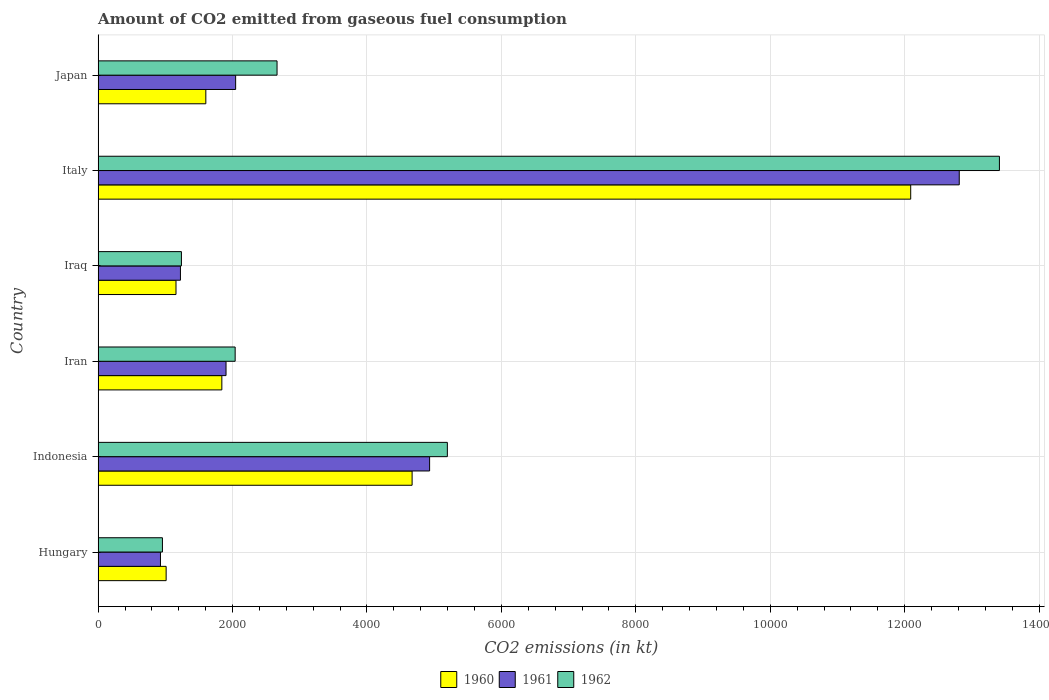How many different coloured bars are there?
Provide a short and direct response. 3. How many groups of bars are there?
Offer a terse response. 6. In how many cases, is the number of bars for a given country not equal to the number of legend labels?
Ensure brevity in your answer.  0. What is the amount of CO2 emitted in 1960 in Hungary?
Your response must be concise. 1012.09. Across all countries, what is the maximum amount of CO2 emitted in 1961?
Offer a terse response. 1.28e+04. Across all countries, what is the minimum amount of CO2 emitted in 1961?
Ensure brevity in your answer.  927.75. In which country was the amount of CO2 emitted in 1960 minimum?
Ensure brevity in your answer.  Hungary. What is the total amount of CO2 emitted in 1962 in the graph?
Provide a succinct answer. 2.55e+04. What is the difference between the amount of CO2 emitted in 1961 in Hungary and that in Iraq?
Provide a short and direct response. -297.03. What is the difference between the amount of CO2 emitted in 1960 in Iran and the amount of CO2 emitted in 1962 in Indonesia?
Keep it short and to the point. -3355.31. What is the average amount of CO2 emitted in 1962 per country?
Offer a very short reply. 4250.66. What is the difference between the amount of CO2 emitted in 1961 and amount of CO2 emitted in 1960 in Hungary?
Provide a succinct answer. -84.34. In how many countries, is the amount of CO2 emitted in 1962 greater than 12000 kt?
Give a very brief answer. 1. What is the ratio of the amount of CO2 emitted in 1962 in Indonesia to that in Japan?
Offer a terse response. 1.95. Is the amount of CO2 emitted in 1962 in Iran less than that in Japan?
Keep it short and to the point. Yes. Is the difference between the amount of CO2 emitted in 1961 in Iran and Italy greater than the difference between the amount of CO2 emitted in 1960 in Iran and Italy?
Offer a very short reply. No. What is the difference between the highest and the second highest amount of CO2 emitted in 1961?
Your answer should be compact. 7880.38. What is the difference between the highest and the lowest amount of CO2 emitted in 1961?
Provide a succinct answer. 1.19e+04. Is the sum of the amount of CO2 emitted in 1960 in Hungary and Iraq greater than the maximum amount of CO2 emitted in 1962 across all countries?
Your response must be concise. No. What does the 1st bar from the top in Iran represents?
Give a very brief answer. 1962. What does the 2nd bar from the bottom in Italy represents?
Ensure brevity in your answer.  1961. Is it the case that in every country, the sum of the amount of CO2 emitted in 1960 and amount of CO2 emitted in 1962 is greater than the amount of CO2 emitted in 1961?
Your answer should be very brief. Yes. What is the difference between two consecutive major ticks on the X-axis?
Provide a succinct answer. 2000. Are the values on the major ticks of X-axis written in scientific E-notation?
Provide a succinct answer. No. What is the title of the graph?
Keep it short and to the point. Amount of CO2 emitted from gaseous fuel consumption. What is the label or title of the X-axis?
Ensure brevity in your answer.  CO2 emissions (in kt). What is the label or title of the Y-axis?
Your response must be concise. Country. What is the CO2 emissions (in kt) in 1960 in Hungary?
Your answer should be very brief. 1012.09. What is the CO2 emissions (in kt) in 1961 in Hungary?
Keep it short and to the point. 927.75. What is the CO2 emissions (in kt) in 1962 in Hungary?
Provide a short and direct response. 957.09. What is the CO2 emissions (in kt) of 1960 in Indonesia?
Your answer should be very brief. 4671.76. What is the CO2 emissions (in kt) of 1961 in Indonesia?
Your response must be concise. 4932.11. What is the CO2 emissions (in kt) in 1962 in Indonesia?
Offer a very short reply. 5196.14. What is the CO2 emissions (in kt) in 1960 in Iran?
Your answer should be compact. 1840.83. What is the CO2 emissions (in kt) of 1961 in Iran?
Provide a short and direct response. 1903.17. What is the CO2 emissions (in kt) of 1962 in Iran?
Ensure brevity in your answer.  2038.85. What is the CO2 emissions (in kt) of 1960 in Iraq?
Offer a very short reply. 1158.77. What is the CO2 emissions (in kt) in 1961 in Iraq?
Offer a very short reply. 1224.78. What is the CO2 emissions (in kt) of 1962 in Iraq?
Your answer should be compact. 1239.45. What is the CO2 emissions (in kt) in 1960 in Italy?
Make the answer very short. 1.21e+04. What is the CO2 emissions (in kt) of 1961 in Italy?
Make the answer very short. 1.28e+04. What is the CO2 emissions (in kt) in 1962 in Italy?
Make the answer very short. 1.34e+04. What is the CO2 emissions (in kt) of 1960 in Japan?
Provide a succinct answer. 1602.48. What is the CO2 emissions (in kt) of 1961 in Japan?
Provide a short and direct response. 2046.19. What is the CO2 emissions (in kt) of 1962 in Japan?
Provide a succinct answer. 2662.24. Across all countries, what is the maximum CO2 emissions (in kt) of 1960?
Your response must be concise. 1.21e+04. Across all countries, what is the maximum CO2 emissions (in kt) in 1961?
Your answer should be compact. 1.28e+04. Across all countries, what is the maximum CO2 emissions (in kt) of 1962?
Your answer should be compact. 1.34e+04. Across all countries, what is the minimum CO2 emissions (in kt) of 1960?
Make the answer very short. 1012.09. Across all countries, what is the minimum CO2 emissions (in kt) in 1961?
Make the answer very short. 927.75. Across all countries, what is the minimum CO2 emissions (in kt) in 1962?
Provide a short and direct response. 957.09. What is the total CO2 emissions (in kt) of 1960 in the graph?
Your response must be concise. 2.24e+04. What is the total CO2 emissions (in kt) of 1961 in the graph?
Keep it short and to the point. 2.38e+04. What is the total CO2 emissions (in kt) in 1962 in the graph?
Your answer should be very brief. 2.55e+04. What is the difference between the CO2 emissions (in kt) of 1960 in Hungary and that in Indonesia?
Give a very brief answer. -3659.67. What is the difference between the CO2 emissions (in kt) in 1961 in Hungary and that in Indonesia?
Give a very brief answer. -4004.36. What is the difference between the CO2 emissions (in kt) in 1962 in Hungary and that in Indonesia?
Provide a short and direct response. -4239.05. What is the difference between the CO2 emissions (in kt) of 1960 in Hungary and that in Iran?
Give a very brief answer. -828.74. What is the difference between the CO2 emissions (in kt) of 1961 in Hungary and that in Iran?
Your response must be concise. -975.42. What is the difference between the CO2 emissions (in kt) of 1962 in Hungary and that in Iran?
Ensure brevity in your answer.  -1081.77. What is the difference between the CO2 emissions (in kt) in 1960 in Hungary and that in Iraq?
Your answer should be compact. -146.68. What is the difference between the CO2 emissions (in kt) of 1961 in Hungary and that in Iraq?
Your response must be concise. -297.03. What is the difference between the CO2 emissions (in kt) in 1962 in Hungary and that in Iraq?
Provide a short and direct response. -282.36. What is the difference between the CO2 emissions (in kt) in 1960 in Hungary and that in Italy?
Provide a succinct answer. -1.11e+04. What is the difference between the CO2 emissions (in kt) in 1961 in Hungary and that in Italy?
Offer a very short reply. -1.19e+04. What is the difference between the CO2 emissions (in kt) in 1962 in Hungary and that in Italy?
Offer a terse response. -1.25e+04. What is the difference between the CO2 emissions (in kt) in 1960 in Hungary and that in Japan?
Give a very brief answer. -590.39. What is the difference between the CO2 emissions (in kt) in 1961 in Hungary and that in Japan?
Provide a short and direct response. -1118.43. What is the difference between the CO2 emissions (in kt) in 1962 in Hungary and that in Japan?
Make the answer very short. -1705.15. What is the difference between the CO2 emissions (in kt) of 1960 in Indonesia and that in Iran?
Your response must be concise. 2830.92. What is the difference between the CO2 emissions (in kt) in 1961 in Indonesia and that in Iran?
Your answer should be very brief. 3028.94. What is the difference between the CO2 emissions (in kt) of 1962 in Indonesia and that in Iran?
Your response must be concise. 3157.29. What is the difference between the CO2 emissions (in kt) in 1960 in Indonesia and that in Iraq?
Keep it short and to the point. 3512.99. What is the difference between the CO2 emissions (in kt) of 1961 in Indonesia and that in Iraq?
Offer a very short reply. 3707.34. What is the difference between the CO2 emissions (in kt) of 1962 in Indonesia and that in Iraq?
Offer a terse response. 3956.69. What is the difference between the CO2 emissions (in kt) in 1960 in Indonesia and that in Italy?
Offer a very short reply. -7418.34. What is the difference between the CO2 emissions (in kt) of 1961 in Indonesia and that in Italy?
Your response must be concise. -7880.38. What is the difference between the CO2 emissions (in kt) in 1962 in Indonesia and that in Italy?
Keep it short and to the point. -8214.08. What is the difference between the CO2 emissions (in kt) in 1960 in Indonesia and that in Japan?
Your answer should be very brief. 3069.28. What is the difference between the CO2 emissions (in kt) of 1961 in Indonesia and that in Japan?
Offer a terse response. 2885.93. What is the difference between the CO2 emissions (in kt) of 1962 in Indonesia and that in Japan?
Provide a short and direct response. 2533.9. What is the difference between the CO2 emissions (in kt) in 1960 in Iran and that in Iraq?
Make the answer very short. 682.06. What is the difference between the CO2 emissions (in kt) in 1961 in Iran and that in Iraq?
Your response must be concise. 678.39. What is the difference between the CO2 emissions (in kt) of 1962 in Iran and that in Iraq?
Your answer should be compact. 799.41. What is the difference between the CO2 emissions (in kt) of 1960 in Iran and that in Italy?
Your answer should be compact. -1.02e+04. What is the difference between the CO2 emissions (in kt) in 1961 in Iran and that in Italy?
Provide a succinct answer. -1.09e+04. What is the difference between the CO2 emissions (in kt) of 1962 in Iran and that in Italy?
Your answer should be compact. -1.14e+04. What is the difference between the CO2 emissions (in kt) of 1960 in Iran and that in Japan?
Give a very brief answer. 238.35. What is the difference between the CO2 emissions (in kt) of 1961 in Iran and that in Japan?
Keep it short and to the point. -143.01. What is the difference between the CO2 emissions (in kt) in 1962 in Iran and that in Japan?
Ensure brevity in your answer.  -623.39. What is the difference between the CO2 emissions (in kt) of 1960 in Iraq and that in Italy?
Your answer should be very brief. -1.09e+04. What is the difference between the CO2 emissions (in kt) in 1961 in Iraq and that in Italy?
Offer a very short reply. -1.16e+04. What is the difference between the CO2 emissions (in kt) of 1962 in Iraq and that in Italy?
Keep it short and to the point. -1.22e+04. What is the difference between the CO2 emissions (in kt) in 1960 in Iraq and that in Japan?
Provide a succinct answer. -443.71. What is the difference between the CO2 emissions (in kt) in 1961 in Iraq and that in Japan?
Offer a terse response. -821.41. What is the difference between the CO2 emissions (in kt) of 1962 in Iraq and that in Japan?
Provide a succinct answer. -1422.8. What is the difference between the CO2 emissions (in kt) in 1960 in Italy and that in Japan?
Make the answer very short. 1.05e+04. What is the difference between the CO2 emissions (in kt) of 1961 in Italy and that in Japan?
Your answer should be very brief. 1.08e+04. What is the difference between the CO2 emissions (in kt) of 1962 in Italy and that in Japan?
Ensure brevity in your answer.  1.07e+04. What is the difference between the CO2 emissions (in kt) of 1960 in Hungary and the CO2 emissions (in kt) of 1961 in Indonesia?
Your answer should be very brief. -3920.02. What is the difference between the CO2 emissions (in kt) of 1960 in Hungary and the CO2 emissions (in kt) of 1962 in Indonesia?
Provide a short and direct response. -4184.05. What is the difference between the CO2 emissions (in kt) in 1961 in Hungary and the CO2 emissions (in kt) in 1962 in Indonesia?
Offer a very short reply. -4268.39. What is the difference between the CO2 emissions (in kt) of 1960 in Hungary and the CO2 emissions (in kt) of 1961 in Iran?
Ensure brevity in your answer.  -891.08. What is the difference between the CO2 emissions (in kt) of 1960 in Hungary and the CO2 emissions (in kt) of 1962 in Iran?
Provide a short and direct response. -1026.76. What is the difference between the CO2 emissions (in kt) in 1961 in Hungary and the CO2 emissions (in kt) in 1962 in Iran?
Offer a very short reply. -1111.1. What is the difference between the CO2 emissions (in kt) in 1960 in Hungary and the CO2 emissions (in kt) in 1961 in Iraq?
Keep it short and to the point. -212.69. What is the difference between the CO2 emissions (in kt) of 1960 in Hungary and the CO2 emissions (in kt) of 1962 in Iraq?
Give a very brief answer. -227.35. What is the difference between the CO2 emissions (in kt) in 1961 in Hungary and the CO2 emissions (in kt) in 1962 in Iraq?
Give a very brief answer. -311.69. What is the difference between the CO2 emissions (in kt) in 1960 in Hungary and the CO2 emissions (in kt) in 1961 in Italy?
Make the answer very short. -1.18e+04. What is the difference between the CO2 emissions (in kt) of 1960 in Hungary and the CO2 emissions (in kt) of 1962 in Italy?
Your answer should be very brief. -1.24e+04. What is the difference between the CO2 emissions (in kt) in 1961 in Hungary and the CO2 emissions (in kt) in 1962 in Italy?
Ensure brevity in your answer.  -1.25e+04. What is the difference between the CO2 emissions (in kt) of 1960 in Hungary and the CO2 emissions (in kt) of 1961 in Japan?
Provide a succinct answer. -1034.09. What is the difference between the CO2 emissions (in kt) of 1960 in Hungary and the CO2 emissions (in kt) of 1962 in Japan?
Offer a terse response. -1650.15. What is the difference between the CO2 emissions (in kt) in 1961 in Hungary and the CO2 emissions (in kt) in 1962 in Japan?
Provide a succinct answer. -1734.49. What is the difference between the CO2 emissions (in kt) of 1960 in Indonesia and the CO2 emissions (in kt) of 1961 in Iran?
Give a very brief answer. 2768.59. What is the difference between the CO2 emissions (in kt) in 1960 in Indonesia and the CO2 emissions (in kt) in 1962 in Iran?
Offer a terse response. 2632.91. What is the difference between the CO2 emissions (in kt) of 1961 in Indonesia and the CO2 emissions (in kt) of 1962 in Iran?
Keep it short and to the point. 2893.26. What is the difference between the CO2 emissions (in kt) in 1960 in Indonesia and the CO2 emissions (in kt) in 1961 in Iraq?
Your answer should be compact. 3446.98. What is the difference between the CO2 emissions (in kt) in 1960 in Indonesia and the CO2 emissions (in kt) in 1962 in Iraq?
Offer a terse response. 3432.31. What is the difference between the CO2 emissions (in kt) of 1961 in Indonesia and the CO2 emissions (in kt) of 1962 in Iraq?
Offer a very short reply. 3692.67. What is the difference between the CO2 emissions (in kt) in 1960 in Indonesia and the CO2 emissions (in kt) in 1961 in Italy?
Offer a terse response. -8140.74. What is the difference between the CO2 emissions (in kt) of 1960 in Indonesia and the CO2 emissions (in kt) of 1962 in Italy?
Offer a very short reply. -8738.46. What is the difference between the CO2 emissions (in kt) of 1961 in Indonesia and the CO2 emissions (in kt) of 1962 in Italy?
Offer a terse response. -8478.1. What is the difference between the CO2 emissions (in kt) of 1960 in Indonesia and the CO2 emissions (in kt) of 1961 in Japan?
Your answer should be very brief. 2625.57. What is the difference between the CO2 emissions (in kt) of 1960 in Indonesia and the CO2 emissions (in kt) of 1962 in Japan?
Your response must be concise. 2009.52. What is the difference between the CO2 emissions (in kt) in 1961 in Indonesia and the CO2 emissions (in kt) in 1962 in Japan?
Your answer should be very brief. 2269.87. What is the difference between the CO2 emissions (in kt) in 1960 in Iran and the CO2 emissions (in kt) in 1961 in Iraq?
Your answer should be compact. 616.06. What is the difference between the CO2 emissions (in kt) in 1960 in Iran and the CO2 emissions (in kt) in 1962 in Iraq?
Provide a short and direct response. 601.39. What is the difference between the CO2 emissions (in kt) of 1961 in Iran and the CO2 emissions (in kt) of 1962 in Iraq?
Your response must be concise. 663.73. What is the difference between the CO2 emissions (in kt) in 1960 in Iran and the CO2 emissions (in kt) in 1961 in Italy?
Keep it short and to the point. -1.10e+04. What is the difference between the CO2 emissions (in kt) of 1960 in Iran and the CO2 emissions (in kt) of 1962 in Italy?
Ensure brevity in your answer.  -1.16e+04. What is the difference between the CO2 emissions (in kt) in 1961 in Iran and the CO2 emissions (in kt) in 1962 in Italy?
Make the answer very short. -1.15e+04. What is the difference between the CO2 emissions (in kt) in 1960 in Iran and the CO2 emissions (in kt) in 1961 in Japan?
Your response must be concise. -205.35. What is the difference between the CO2 emissions (in kt) in 1960 in Iran and the CO2 emissions (in kt) in 1962 in Japan?
Ensure brevity in your answer.  -821.41. What is the difference between the CO2 emissions (in kt) in 1961 in Iran and the CO2 emissions (in kt) in 1962 in Japan?
Ensure brevity in your answer.  -759.07. What is the difference between the CO2 emissions (in kt) in 1960 in Iraq and the CO2 emissions (in kt) in 1961 in Italy?
Provide a succinct answer. -1.17e+04. What is the difference between the CO2 emissions (in kt) of 1960 in Iraq and the CO2 emissions (in kt) of 1962 in Italy?
Offer a terse response. -1.23e+04. What is the difference between the CO2 emissions (in kt) in 1961 in Iraq and the CO2 emissions (in kt) in 1962 in Italy?
Provide a succinct answer. -1.22e+04. What is the difference between the CO2 emissions (in kt) in 1960 in Iraq and the CO2 emissions (in kt) in 1961 in Japan?
Your answer should be compact. -887.41. What is the difference between the CO2 emissions (in kt) of 1960 in Iraq and the CO2 emissions (in kt) of 1962 in Japan?
Offer a terse response. -1503.47. What is the difference between the CO2 emissions (in kt) in 1961 in Iraq and the CO2 emissions (in kt) in 1962 in Japan?
Provide a short and direct response. -1437.46. What is the difference between the CO2 emissions (in kt) in 1960 in Italy and the CO2 emissions (in kt) in 1961 in Japan?
Give a very brief answer. 1.00e+04. What is the difference between the CO2 emissions (in kt) of 1960 in Italy and the CO2 emissions (in kt) of 1962 in Japan?
Keep it short and to the point. 9427.86. What is the difference between the CO2 emissions (in kt) of 1961 in Italy and the CO2 emissions (in kt) of 1962 in Japan?
Provide a short and direct response. 1.02e+04. What is the average CO2 emissions (in kt) of 1960 per country?
Ensure brevity in your answer.  3729.34. What is the average CO2 emissions (in kt) of 1961 per country?
Give a very brief answer. 3974.42. What is the average CO2 emissions (in kt) of 1962 per country?
Ensure brevity in your answer.  4250.66. What is the difference between the CO2 emissions (in kt) in 1960 and CO2 emissions (in kt) in 1961 in Hungary?
Offer a very short reply. 84.34. What is the difference between the CO2 emissions (in kt) in 1960 and CO2 emissions (in kt) in 1962 in Hungary?
Keep it short and to the point. 55.01. What is the difference between the CO2 emissions (in kt) of 1961 and CO2 emissions (in kt) of 1962 in Hungary?
Offer a very short reply. -29.34. What is the difference between the CO2 emissions (in kt) in 1960 and CO2 emissions (in kt) in 1961 in Indonesia?
Offer a very short reply. -260.36. What is the difference between the CO2 emissions (in kt) in 1960 and CO2 emissions (in kt) in 1962 in Indonesia?
Provide a succinct answer. -524.38. What is the difference between the CO2 emissions (in kt) of 1961 and CO2 emissions (in kt) of 1962 in Indonesia?
Your answer should be compact. -264.02. What is the difference between the CO2 emissions (in kt) of 1960 and CO2 emissions (in kt) of 1961 in Iran?
Make the answer very short. -62.34. What is the difference between the CO2 emissions (in kt) in 1960 and CO2 emissions (in kt) in 1962 in Iran?
Offer a terse response. -198.02. What is the difference between the CO2 emissions (in kt) in 1961 and CO2 emissions (in kt) in 1962 in Iran?
Your answer should be very brief. -135.68. What is the difference between the CO2 emissions (in kt) of 1960 and CO2 emissions (in kt) of 1961 in Iraq?
Make the answer very short. -66.01. What is the difference between the CO2 emissions (in kt) of 1960 and CO2 emissions (in kt) of 1962 in Iraq?
Your answer should be compact. -80.67. What is the difference between the CO2 emissions (in kt) in 1961 and CO2 emissions (in kt) in 1962 in Iraq?
Offer a very short reply. -14.67. What is the difference between the CO2 emissions (in kt) in 1960 and CO2 emissions (in kt) in 1961 in Italy?
Provide a succinct answer. -722.4. What is the difference between the CO2 emissions (in kt) of 1960 and CO2 emissions (in kt) of 1962 in Italy?
Your answer should be very brief. -1320.12. What is the difference between the CO2 emissions (in kt) in 1961 and CO2 emissions (in kt) in 1962 in Italy?
Make the answer very short. -597.72. What is the difference between the CO2 emissions (in kt) in 1960 and CO2 emissions (in kt) in 1961 in Japan?
Ensure brevity in your answer.  -443.71. What is the difference between the CO2 emissions (in kt) in 1960 and CO2 emissions (in kt) in 1962 in Japan?
Provide a short and direct response. -1059.76. What is the difference between the CO2 emissions (in kt) of 1961 and CO2 emissions (in kt) of 1962 in Japan?
Ensure brevity in your answer.  -616.06. What is the ratio of the CO2 emissions (in kt) in 1960 in Hungary to that in Indonesia?
Make the answer very short. 0.22. What is the ratio of the CO2 emissions (in kt) in 1961 in Hungary to that in Indonesia?
Your answer should be compact. 0.19. What is the ratio of the CO2 emissions (in kt) in 1962 in Hungary to that in Indonesia?
Offer a terse response. 0.18. What is the ratio of the CO2 emissions (in kt) in 1960 in Hungary to that in Iran?
Your answer should be very brief. 0.55. What is the ratio of the CO2 emissions (in kt) of 1961 in Hungary to that in Iran?
Offer a very short reply. 0.49. What is the ratio of the CO2 emissions (in kt) of 1962 in Hungary to that in Iran?
Give a very brief answer. 0.47. What is the ratio of the CO2 emissions (in kt) in 1960 in Hungary to that in Iraq?
Your answer should be compact. 0.87. What is the ratio of the CO2 emissions (in kt) of 1961 in Hungary to that in Iraq?
Your response must be concise. 0.76. What is the ratio of the CO2 emissions (in kt) in 1962 in Hungary to that in Iraq?
Provide a short and direct response. 0.77. What is the ratio of the CO2 emissions (in kt) in 1960 in Hungary to that in Italy?
Give a very brief answer. 0.08. What is the ratio of the CO2 emissions (in kt) of 1961 in Hungary to that in Italy?
Your answer should be compact. 0.07. What is the ratio of the CO2 emissions (in kt) of 1962 in Hungary to that in Italy?
Offer a very short reply. 0.07. What is the ratio of the CO2 emissions (in kt) of 1960 in Hungary to that in Japan?
Your answer should be very brief. 0.63. What is the ratio of the CO2 emissions (in kt) of 1961 in Hungary to that in Japan?
Ensure brevity in your answer.  0.45. What is the ratio of the CO2 emissions (in kt) in 1962 in Hungary to that in Japan?
Your response must be concise. 0.36. What is the ratio of the CO2 emissions (in kt) of 1960 in Indonesia to that in Iran?
Your answer should be very brief. 2.54. What is the ratio of the CO2 emissions (in kt) of 1961 in Indonesia to that in Iran?
Your answer should be compact. 2.59. What is the ratio of the CO2 emissions (in kt) of 1962 in Indonesia to that in Iran?
Offer a very short reply. 2.55. What is the ratio of the CO2 emissions (in kt) in 1960 in Indonesia to that in Iraq?
Make the answer very short. 4.03. What is the ratio of the CO2 emissions (in kt) of 1961 in Indonesia to that in Iraq?
Offer a terse response. 4.03. What is the ratio of the CO2 emissions (in kt) in 1962 in Indonesia to that in Iraq?
Your answer should be compact. 4.19. What is the ratio of the CO2 emissions (in kt) in 1960 in Indonesia to that in Italy?
Keep it short and to the point. 0.39. What is the ratio of the CO2 emissions (in kt) in 1961 in Indonesia to that in Italy?
Ensure brevity in your answer.  0.38. What is the ratio of the CO2 emissions (in kt) in 1962 in Indonesia to that in Italy?
Your response must be concise. 0.39. What is the ratio of the CO2 emissions (in kt) in 1960 in Indonesia to that in Japan?
Your answer should be compact. 2.92. What is the ratio of the CO2 emissions (in kt) in 1961 in Indonesia to that in Japan?
Give a very brief answer. 2.41. What is the ratio of the CO2 emissions (in kt) in 1962 in Indonesia to that in Japan?
Offer a terse response. 1.95. What is the ratio of the CO2 emissions (in kt) of 1960 in Iran to that in Iraq?
Your answer should be compact. 1.59. What is the ratio of the CO2 emissions (in kt) of 1961 in Iran to that in Iraq?
Keep it short and to the point. 1.55. What is the ratio of the CO2 emissions (in kt) in 1962 in Iran to that in Iraq?
Your answer should be very brief. 1.65. What is the ratio of the CO2 emissions (in kt) in 1960 in Iran to that in Italy?
Provide a short and direct response. 0.15. What is the ratio of the CO2 emissions (in kt) of 1961 in Iran to that in Italy?
Offer a terse response. 0.15. What is the ratio of the CO2 emissions (in kt) of 1962 in Iran to that in Italy?
Provide a short and direct response. 0.15. What is the ratio of the CO2 emissions (in kt) in 1960 in Iran to that in Japan?
Offer a very short reply. 1.15. What is the ratio of the CO2 emissions (in kt) in 1961 in Iran to that in Japan?
Your answer should be very brief. 0.93. What is the ratio of the CO2 emissions (in kt) in 1962 in Iran to that in Japan?
Your answer should be very brief. 0.77. What is the ratio of the CO2 emissions (in kt) of 1960 in Iraq to that in Italy?
Offer a terse response. 0.1. What is the ratio of the CO2 emissions (in kt) in 1961 in Iraq to that in Italy?
Ensure brevity in your answer.  0.1. What is the ratio of the CO2 emissions (in kt) in 1962 in Iraq to that in Italy?
Your answer should be very brief. 0.09. What is the ratio of the CO2 emissions (in kt) of 1960 in Iraq to that in Japan?
Your response must be concise. 0.72. What is the ratio of the CO2 emissions (in kt) of 1961 in Iraq to that in Japan?
Your response must be concise. 0.6. What is the ratio of the CO2 emissions (in kt) of 1962 in Iraq to that in Japan?
Your answer should be very brief. 0.47. What is the ratio of the CO2 emissions (in kt) of 1960 in Italy to that in Japan?
Your answer should be compact. 7.54. What is the ratio of the CO2 emissions (in kt) of 1961 in Italy to that in Japan?
Give a very brief answer. 6.26. What is the ratio of the CO2 emissions (in kt) of 1962 in Italy to that in Japan?
Make the answer very short. 5.04. What is the difference between the highest and the second highest CO2 emissions (in kt) in 1960?
Offer a terse response. 7418.34. What is the difference between the highest and the second highest CO2 emissions (in kt) of 1961?
Provide a succinct answer. 7880.38. What is the difference between the highest and the second highest CO2 emissions (in kt) of 1962?
Make the answer very short. 8214.08. What is the difference between the highest and the lowest CO2 emissions (in kt) in 1960?
Offer a terse response. 1.11e+04. What is the difference between the highest and the lowest CO2 emissions (in kt) in 1961?
Ensure brevity in your answer.  1.19e+04. What is the difference between the highest and the lowest CO2 emissions (in kt) of 1962?
Keep it short and to the point. 1.25e+04. 